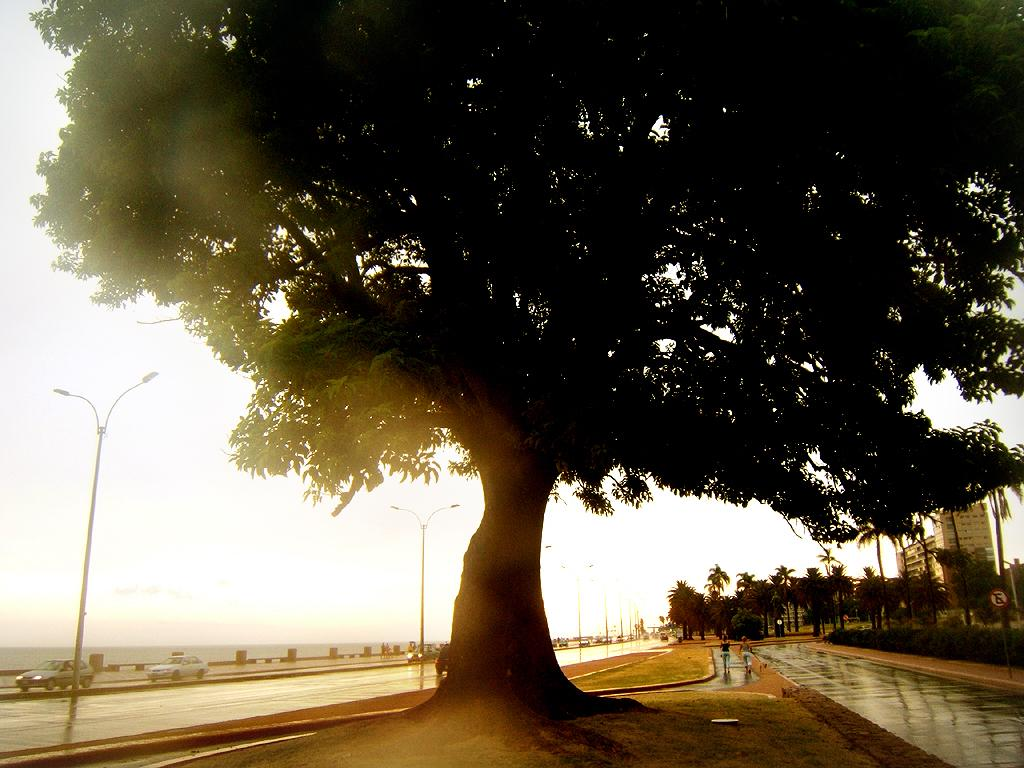What is one of the main features in the image? There is a tree in the image. What else can be seen in the image? There are vehicles on the road and lights on poles in the image. What can be seen in the background of the image? There are trees, a board on a pole, persons, buildings, and the sky visible in the background of the image. Can you see a lake in the image? No, there is no lake present in the image. What type of pet can be seen playing with the persons in the image? There are no pets visible in the image. 